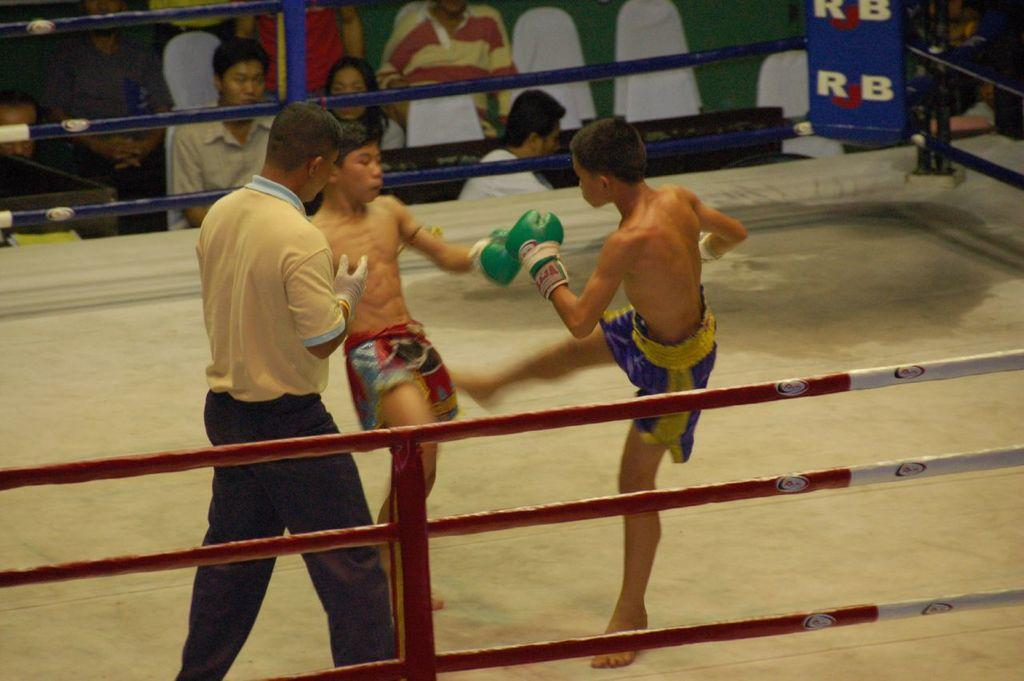<image>
Write a terse but informative summary of the picture. Two men boxing in a ring that says RJB on the side. 